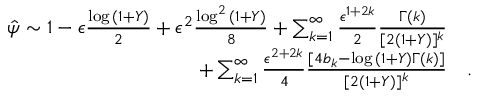Convert formula to latex. <formula><loc_0><loc_0><loc_500><loc_500>\begin{array} { r l } { \hat { \psi } \sim 1 - \epsilon \frac { \log { ( 1 + Y ) } } { 2 } + \epsilon ^ { 2 } \frac { \log ^ { 2 } { ( 1 + Y ) } } { 8 } + \sum _ { k = 1 } ^ { \infty } \frac { \epsilon ^ { 1 + 2 k } } { 2 } \frac { \Gamma ( k ) } { [ 2 ( 1 + Y ) ] ^ { k } } } \\ { + \sum _ { k = 1 } ^ { \infty } \frac { \epsilon ^ { 2 + 2 k } } { 4 } \frac { [ 4 b _ { k } - \log { ( 1 + Y ) } \Gamma ( k ) ] } { [ 2 ( 1 + Y ) ] ^ { k } } } & { . } \end{array}</formula> 